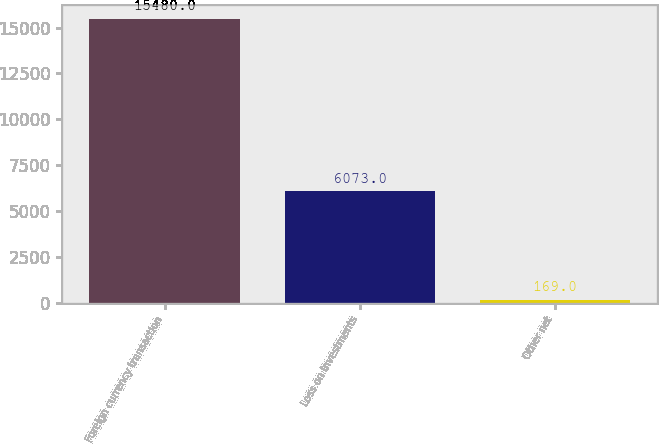<chart> <loc_0><loc_0><loc_500><loc_500><bar_chart><fcel>Foreign currency transaction<fcel>Loss on investments<fcel>Other net<nl><fcel>15480<fcel>6073<fcel>169<nl></chart> 